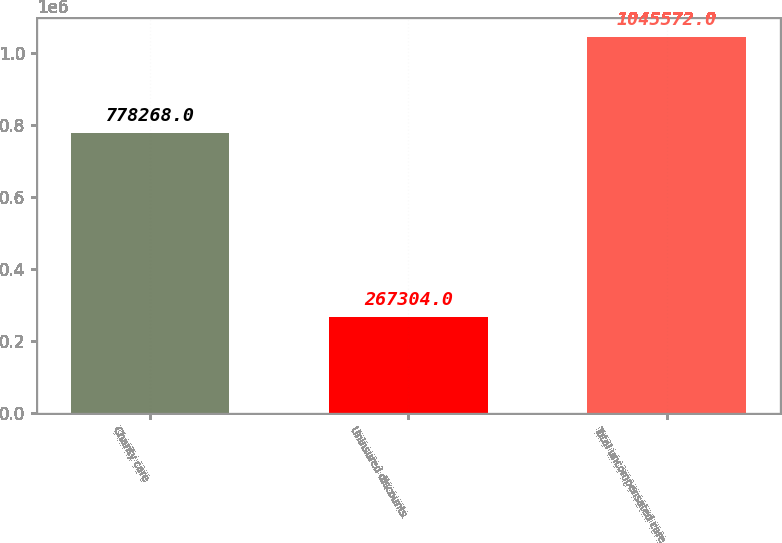<chart> <loc_0><loc_0><loc_500><loc_500><bar_chart><fcel>Charity care<fcel>Uninsured discounts<fcel>Total uncompensated care<nl><fcel>778268<fcel>267304<fcel>1.04557e+06<nl></chart> 